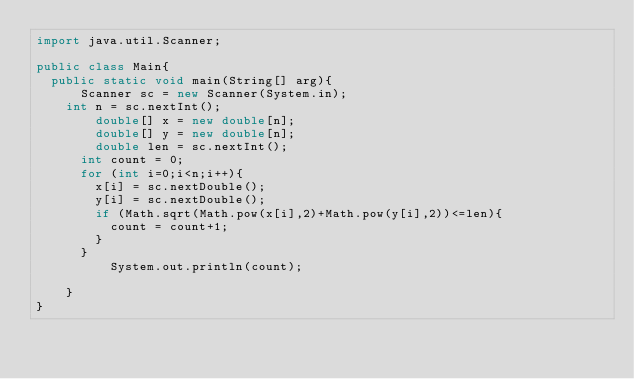<code> <loc_0><loc_0><loc_500><loc_500><_Java_>import java.util.Scanner;

public class Main{
	public static void main(String[] arg){
  		Scanner sc = new Scanner(System.in);
		int n = sc.nextInt();
      	double[] x = new double[n];
      	double[] y = new double[n];
      	double len = sc.nextInt();
      int count = 0;
      for (int i=0;i<n;i++){
        x[i] = sc.nextDouble();
        y[i] = sc.nextDouble();
        if (Math.sqrt(Math.pow(x[i],2)+Math.pow(y[i],2))<=len){
          count = count+1;
        }
      }
          System.out.println(count);
        
    }
}</code> 